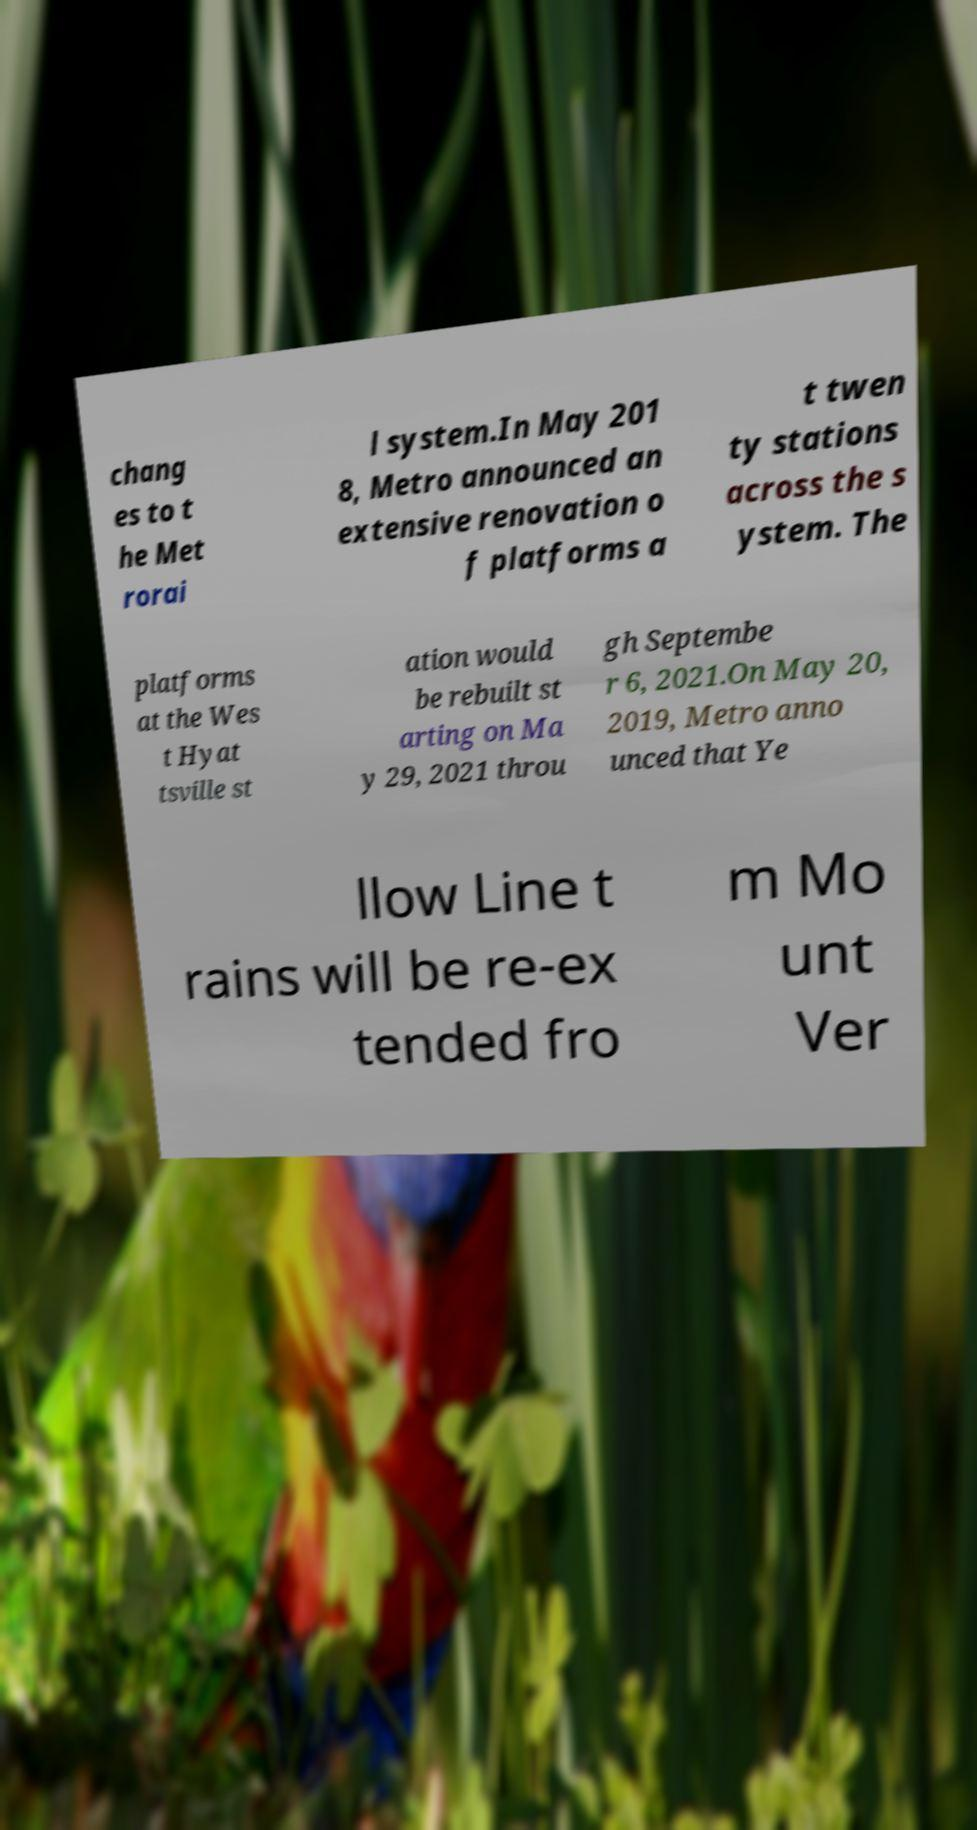Could you assist in decoding the text presented in this image and type it out clearly? chang es to t he Met rorai l system.In May 201 8, Metro announced an extensive renovation o f platforms a t twen ty stations across the s ystem. The platforms at the Wes t Hyat tsville st ation would be rebuilt st arting on Ma y 29, 2021 throu gh Septembe r 6, 2021.On May 20, 2019, Metro anno unced that Ye llow Line t rains will be re-ex tended fro m Mo unt Ver 